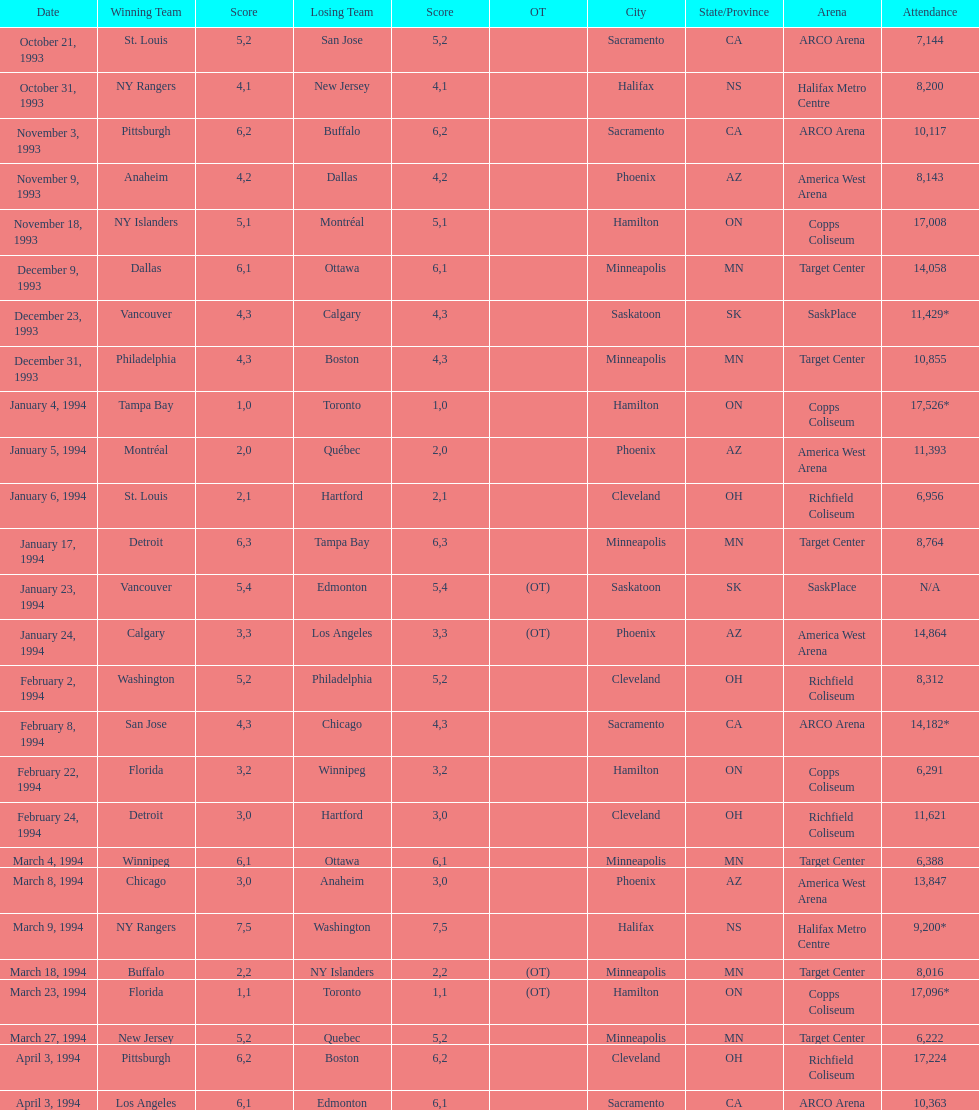How much higher was the attendance at the november 18, 1993 games compared to the november 9th game? 8865. 